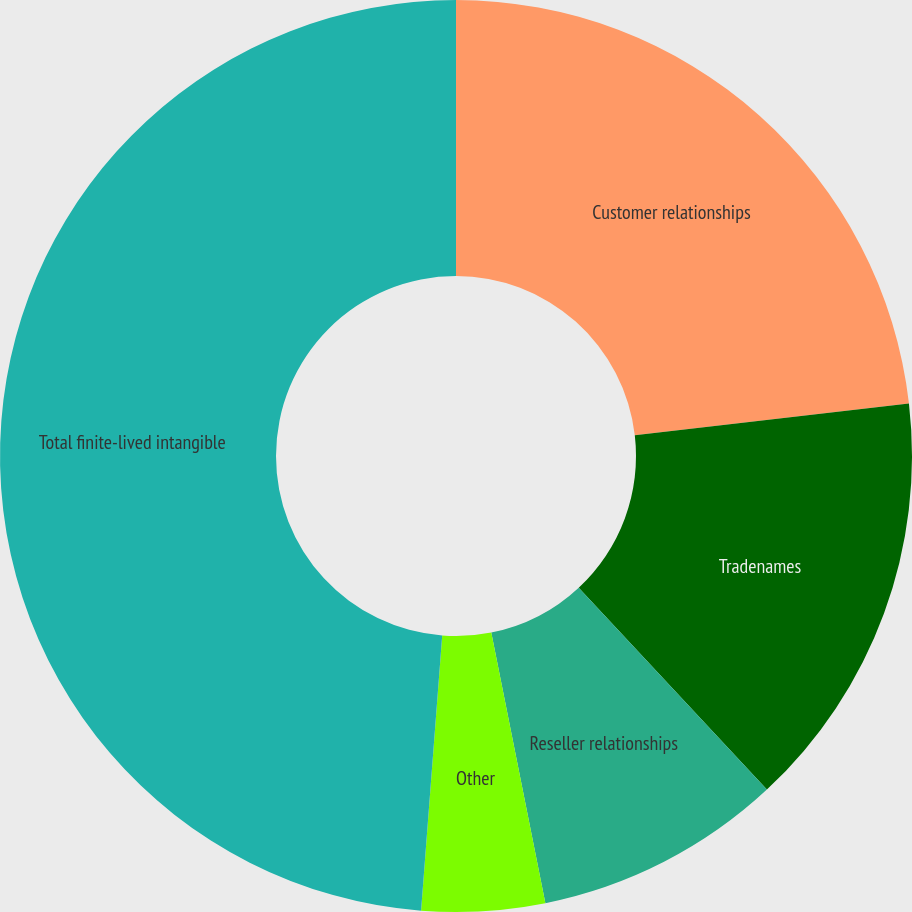<chart> <loc_0><loc_0><loc_500><loc_500><pie_chart><fcel>Customer relationships<fcel>Tradenames<fcel>Reseller relationships<fcel>Other<fcel>Total finite-lived intangible<nl><fcel>23.16%<fcel>14.9%<fcel>8.8%<fcel>4.36%<fcel>48.78%<nl></chart> 